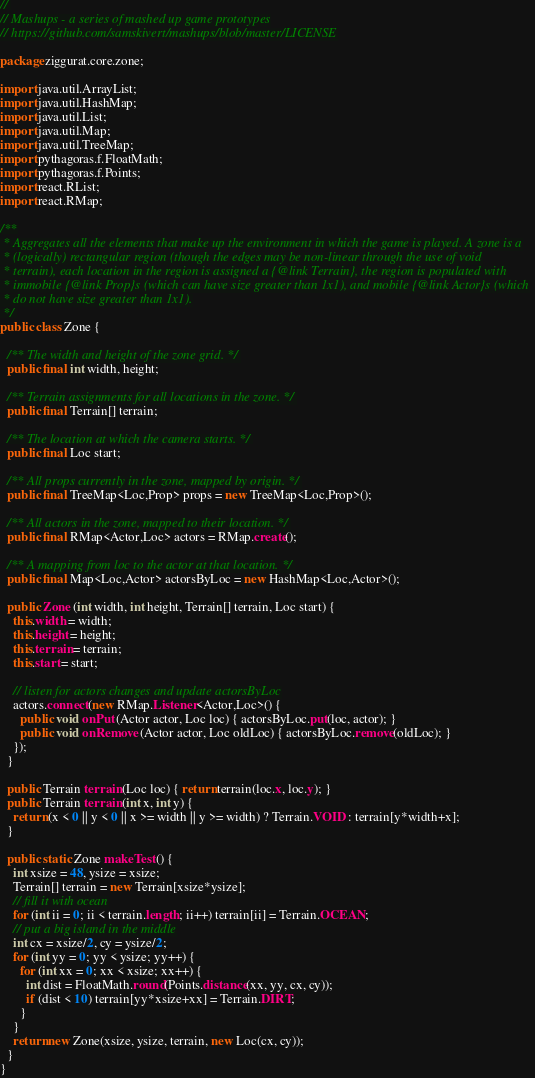<code> <loc_0><loc_0><loc_500><loc_500><_Java_>//
// Mashups - a series of mashed up game prototypes
// https://github.com/samskivert/mashups/blob/master/LICENSE

package ziggurat.core.zone;

import java.util.ArrayList;
import java.util.HashMap;
import java.util.List;
import java.util.Map;
import java.util.TreeMap;
import pythagoras.f.FloatMath;
import pythagoras.f.Points;
import react.RList;
import react.RMap;

/**
 * Aggregates all the elements that make up the environment in which the game is played. A zone is a
 * (logically) rectangular region (though the edges may be non-linear through the use of void
 * terrain), each location in the region is assigned a {@link Terrain}, the region is populated with
 * immobile {@link Prop}s (which can have size greater than 1x1), and mobile {@link Actor}s (which
 * do not have size greater than 1x1).
 */
public class Zone {

  /** The width and height of the zone grid. */
  public final int width, height;

  /** Terrain assignments for all locations in the zone. */
  public final Terrain[] terrain;

  /** The location at which the camera starts. */
  public final Loc start;

  /** All props currently in the zone, mapped by origin. */
  public final TreeMap<Loc,Prop> props = new TreeMap<Loc,Prop>();

  /** All actors in the zone, mapped to their location. */
  public final RMap<Actor,Loc> actors = RMap.create();

  /** A mapping from loc to the actor at that location. */
  public final Map<Loc,Actor> actorsByLoc = new HashMap<Loc,Actor>();

  public Zone (int width, int height, Terrain[] terrain, Loc start) {
    this.width = width;
    this.height = height;
    this.terrain = terrain;
    this.start = start;

    // listen for actors changes and update actorsByLoc
    actors.connect(new RMap.Listener<Actor,Loc>() {
      public void onPut (Actor actor, Loc loc) { actorsByLoc.put(loc, actor); }
      public void onRemove (Actor actor, Loc oldLoc) { actorsByLoc.remove(oldLoc); }
    });
  }

  public Terrain terrain (Loc loc) { return terrain(loc.x, loc.y); }
  public Terrain terrain (int x, int y) {
    return (x < 0 || y < 0 || x >= width || y >= width) ? Terrain.VOID : terrain[y*width+x];
  }

  public static Zone makeTest () {
    int xsize = 48, ysize = xsize;
    Terrain[] terrain = new Terrain[xsize*ysize];
    // fill it with ocean
    for (int ii = 0; ii < terrain.length; ii++) terrain[ii] = Terrain.OCEAN;
    // put a big island in the middle
    int cx = xsize/2, cy = ysize/2;
    for (int yy = 0; yy < ysize; yy++) {
      for (int xx = 0; xx < xsize; xx++) {
        int dist = FloatMath.round(Points.distance(xx, yy, cx, cy));
        if (dist < 10) terrain[yy*xsize+xx] = Terrain.DIRT;
      }
    }
    return new Zone(xsize, ysize, terrain, new Loc(cx, cy));
  }
}
</code> 